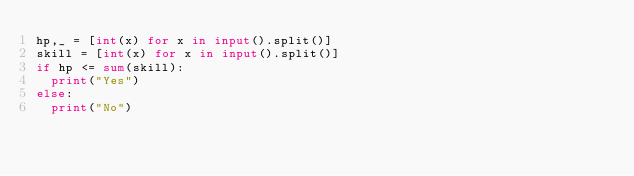Convert code to text. <code><loc_0><loc_0><loc_500><loc_500><_Python_>hp,_ = [int(x) for x in input().split()]
skill = [int(x) for x in input().split()]
if hp <= sum(skill):
  print("Yes")
else:
  print("No")</code> 